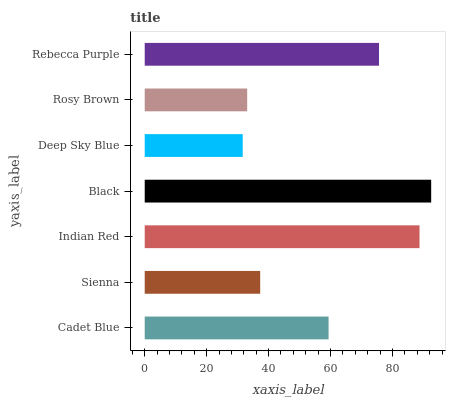Is Deep Sky Blue the minimum?
Answer yes or no. Yes. Is Black the maximum?
Answer yes or no. Yes. Is Sienna the minimum?
Answer yes or no. No. Is Sienna the maximum?
Answer yes or no. No. Is Cadet Blue greater than Sienna?
Answer yes or no. Yes. Is Sienna less than Cadet Blue?
Answer yes or no. Yes. Is Sienna greater than Cadet Blue?
Answer yes or no. No. Is Cadet Blue less than Sienna?
Answer yes or no. No. Is Cadet Blue the high median?
Answer yes or no. Yes. Is Cadet Blue the low median?
Answer yes or no. Yes. Is Indian Red the high median?
Answer yes or no. No. Is Rebecca Purple the low median?
Answer yes or no. No. 